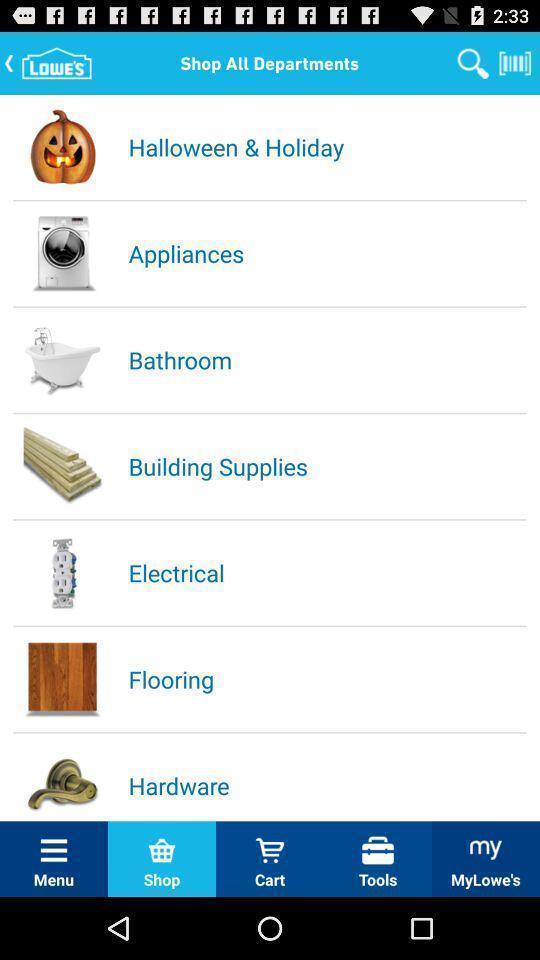Tell me about the visual elements in this screen capture. Screen showing categories to shop. 